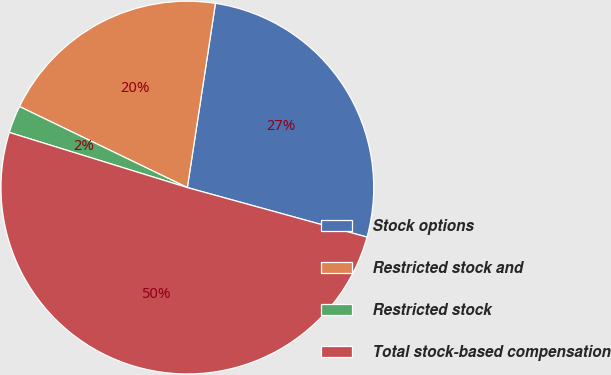<chart> <loc_0><loc_0><loc_500><loc_500><pie_chart><fcel>Stock options<fcel>Restricted stock and<fcel>Restricted stock<fcel>Total stock-based compensation<nl><fcel>26.87%<fcel>20.25%<fcel>2.38%<fcel>50.5%<nl></chart> 